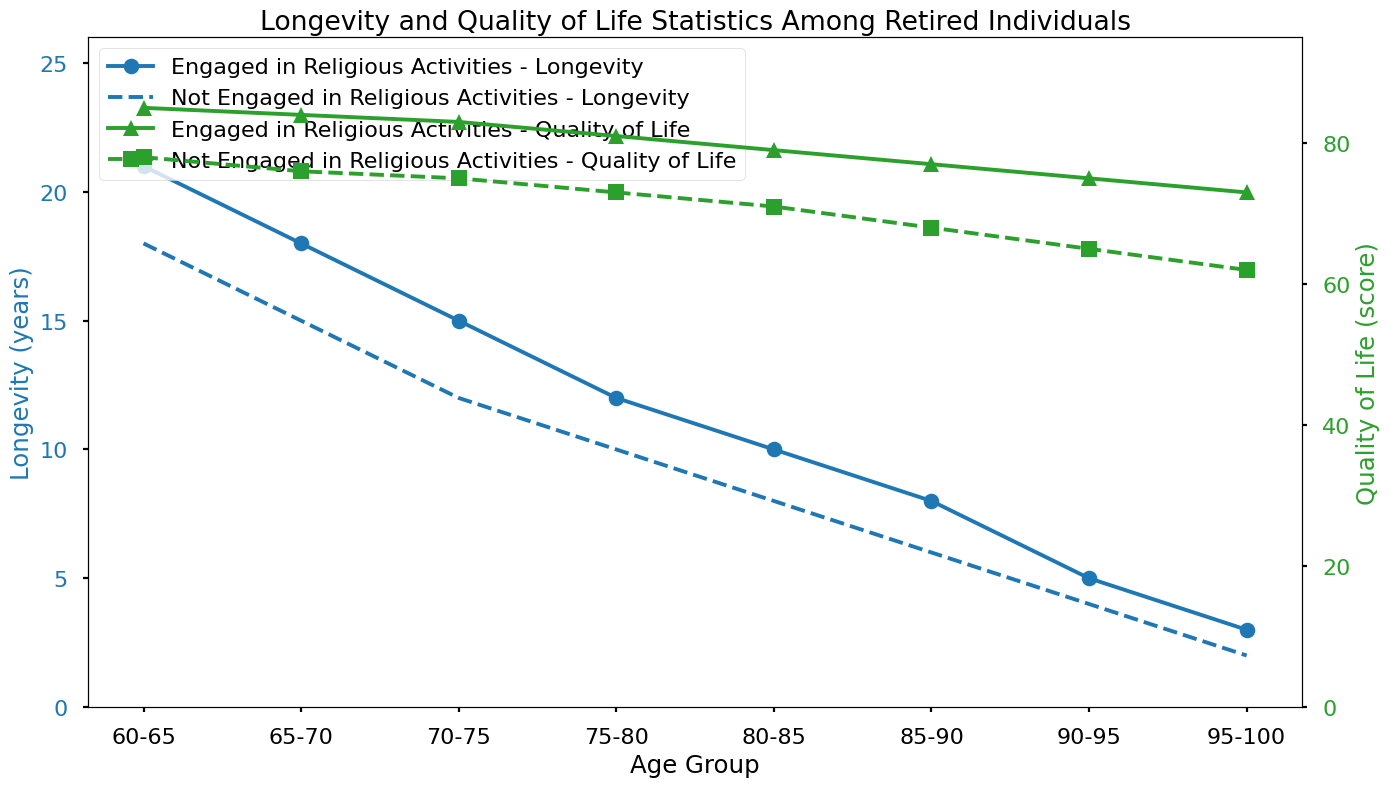Which age group has the highest longevity for those engaged in religious activities? Look for the highest point on the blue line with circles, which represents longevity for those engaged in religious activities. Observe the age group corresponding to this point.
Answer: 60-65 How does quality of life compare between those engaged in religious activities and those who aren't in the 70-75 age group? Examine the green lines in the 70-75 age group. The quality of life score for those engaged in religious activities is represented by the green line with triangles, while the score for those not engaged is represented by the green line with squares. Compare these two scores.
Answer: 83 vs. 75 What is the difference in longevity between those engaged and not engaged in religious activities for the 85-90 age group? Observe the blue lines and look for the values in the 85-90 age group. The longevity for those engaged in religious activities is represented by circles and for those not engaged by x's. Subtract the latter value from the former.
Answer: 8 - 6 = 2 Which age group has the smallest gap in quality of life scores between those engaged in religious activities and those who aren't? Compare the differences between the green lines for each age group. The green line with triangles represents those engaged in religious activities, and the green line with squares represents those who aren't. Identify the age group with the smallest difference between these lines.
Answer: 90-95 What is the overall trend in quality of life for both groups as age increases? Look at the green lines representing quality of life. Observe how the heights of both lines change from the 60-65 age group to the 95-100 age group. Explain whether they generally increase, decrease, or stay the same.
Answer: Decrease How many more years of longevity do those engaged in religious activities have compared to those who aren't in the 75-80 age group? Look at the blue lines in the 75-80 age group. The longevity for those engaged in religious activities is represented by the blue line with circles, and for those not engaged by the blue line with x's. Subtract the latter value from the former.
Answer: 12 - 10 = 2 In terms of quality of life, which age group has the highest score for those not engaged in religious activities? Find the highest point on the green line with squares, which represents quality of life for those not engaged in religious activities. Identify the corresponding age group.
Answer: 60-65 Calculate the average longevity for those engaged in religious activities over all the age groups. Sum the longevity values for those engaged in religious activities across all age groups and then divide by the number of age groups (8). (21 + 18 + 15 + 12 + 10 + 8 + 5 + 3) / 8 = 92 / 8 = 11.5
Answer: 11.5 What is the overall trend in longevity for both groups as people age? Observe the blue lines representing longevity. Look for whether they generally increase, decrease, or stay the same as age progresses from 60-65 to 95-100.
Answer: Decrease 